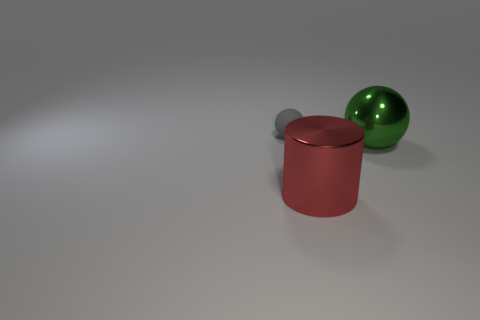Add 1 green shiny objects. How many objects exist? 4 Subtract all balls. How many objects are left? 1 Subtract all small red spheres. Subtract all large objects. How many objects are left? 1 Add 3 large green shiny objects. How many large green shiny objects are left? 4 Add 1 tiny gray metal cylinders. How many tiny gray metal cylinders exist? 1 Subtract 0 cyan balls. How many objects are left? 3 